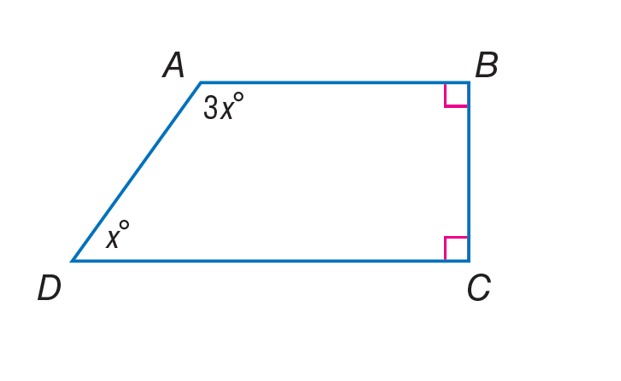Answer the mathemtical geometry problem and directly provide the correct option letter.
Question: Find \angle D of quadrilateral A B C D.
Choices: A: 45 B: 90 C: 135 D: 180 A 